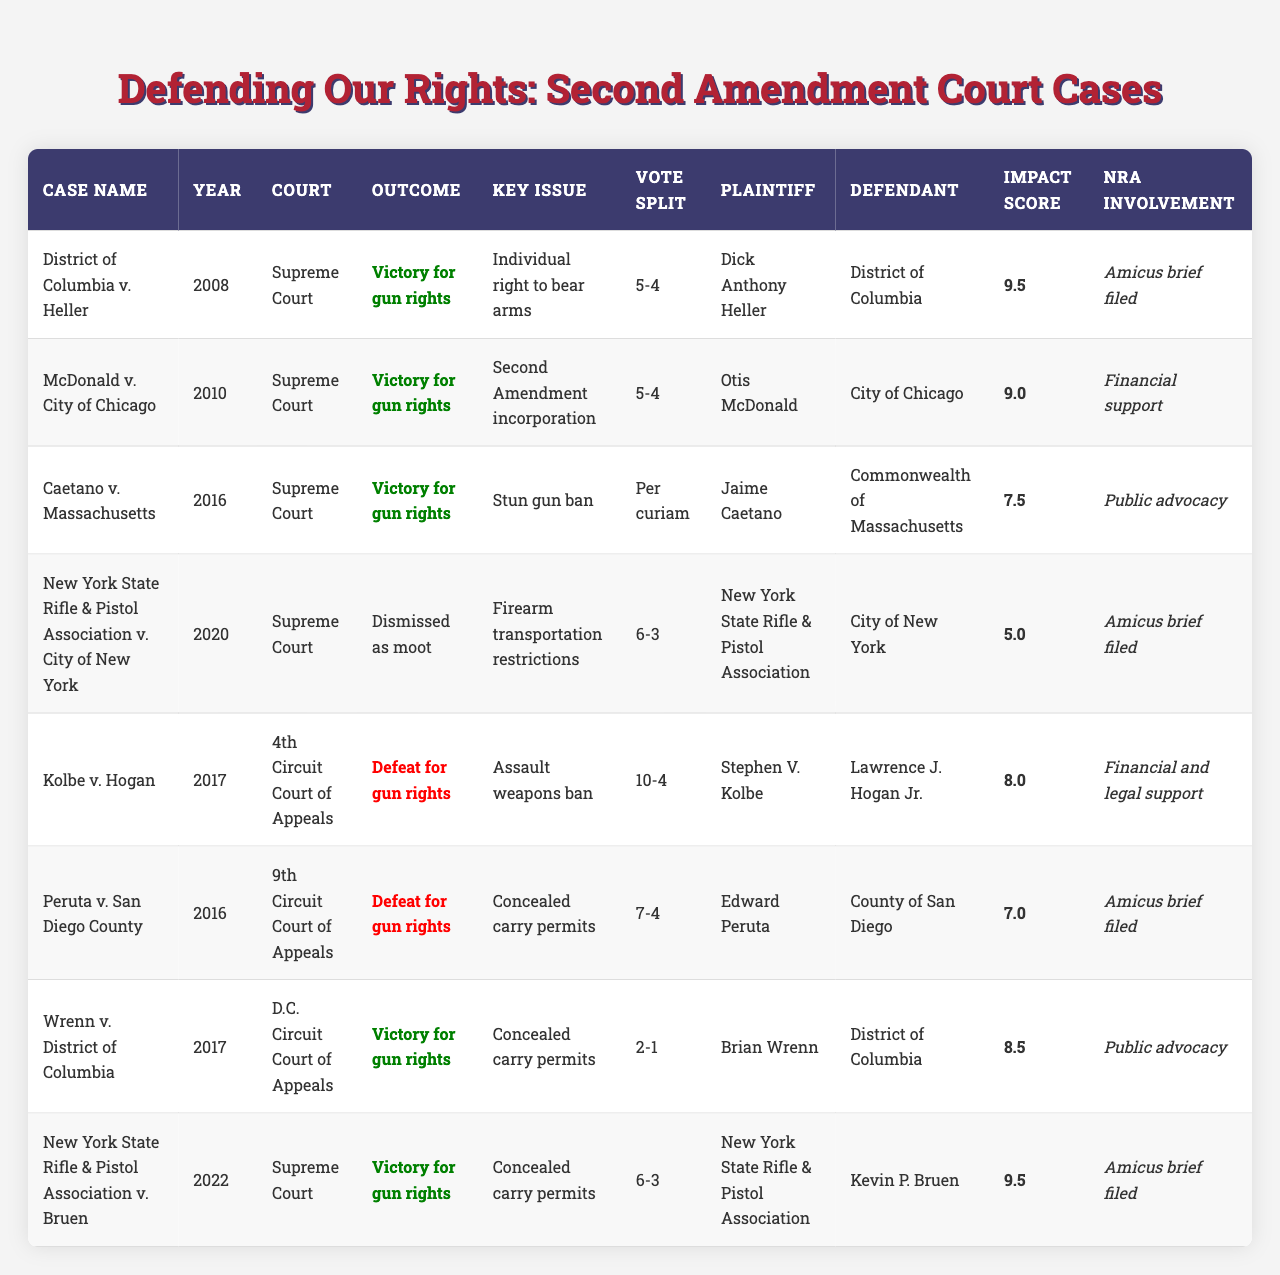What was the outcome of the case "District of Columbia v. Heller"? The table shows that the outcome of "District of Columbia v. Heller" was a "Victory for gun rights."
Answer: Victory for gun rights Which year did the case "McDonald v. City of Chicago" take place? The table indicates that "McDonald v. City of Chicago" occurred in the year 2010.
Answer: 2010 How many Supreme Court cases resulted in a victory for gun rights? By reviewing the table, we find that there are five Supreme Court cases with the outcome listed as a victory for gun rights.
Answer: 5 Which court decided the case with the highest impact score? The table shows that the case with the highest impact score is "District of Columbia v. Heller," decided by the Supreme Court.
Answer: Supreme Court Did the NRA file an amicus brief in the case "New York State Rifle & Pistol Association v. Bruen"? According to the table, the NRA did file an amicus brief in "New York State Rifle & Pistol Association v. Bruen."
Answer: Yes What is the average impact score of the cases decided by the Supreme Court? To find the average, we add the impact scores of the Supreme Court cases (9.5 + 9.0 + 7.5 + 5.0 + 9.5) = 40.5 and divide by the number of cases, which is 5. Thus, the average impact score is 40.5/5 = 8.1.
Answer: 8.1 Which case had a vote split of 6-3? The table identifies the case with a vote split of 6-3 as "New York State Rifle & Pistol Association v. Bruen."
Answer: New York State Rifle & Pistol Association v. Bruen List the plaintiffs for cases with a vote split of 5-4. The plaintiffs for cases with a vote split of 5-4 are Dick Anthony Heller from "District of Columbia v. Heller" and Otis McDonald from "McDonald v. City of Chicago."
Answer: Dick Anthony Heller, Otis McDonald How many cases had the outcome classified as a defeat for gun rights? Upon reviewing the table, we see there are two cases classified as a defeat for gun rights.
Answer: 2 Was "Kolbe v. Hogan" decided by a Supreme Court? The table indicates that "Kolbe v. Hogan" was decided by the 4th Circuit Court of Appeals, not the Supreme Court.
Answer: No What percentage of the cases listed had NRA involvement as "Financial support"? There are three cases with "Financial support" from the NRA out of eight total cases, resulting in a percentage of (3/8) * 100 = 37.5%.
Answer: 37.5% 